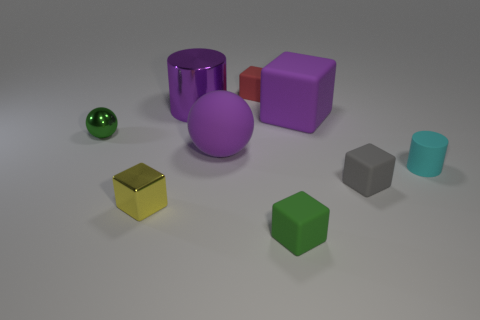Subtract all large cubes. How many cubes are left? 4 Subtract all cyan cylinders. How many cylinders are left? 1 Subtract 3 cubes. How many cubes are left? 2 Subtract all spheres. How many objects are left? 7 Subtract all gray cylinders. Subtract all gray balls. How many cylinders are left? 2 Subtract all tiny blue rubber things. Subtract all small blocks. How many objects are left? 5 Add 5 small matte cylinders. How many small matte cylinders are left? 6 Add 9 tiny red cylinders. How many tiny red cylinders exist? 9 Subtract 1 green balls. How many objects are left? 8 